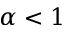Convert formula to latex. <formula><loc_0><loc_0><loc_500><loc_500>\alpha < 1</formula> 